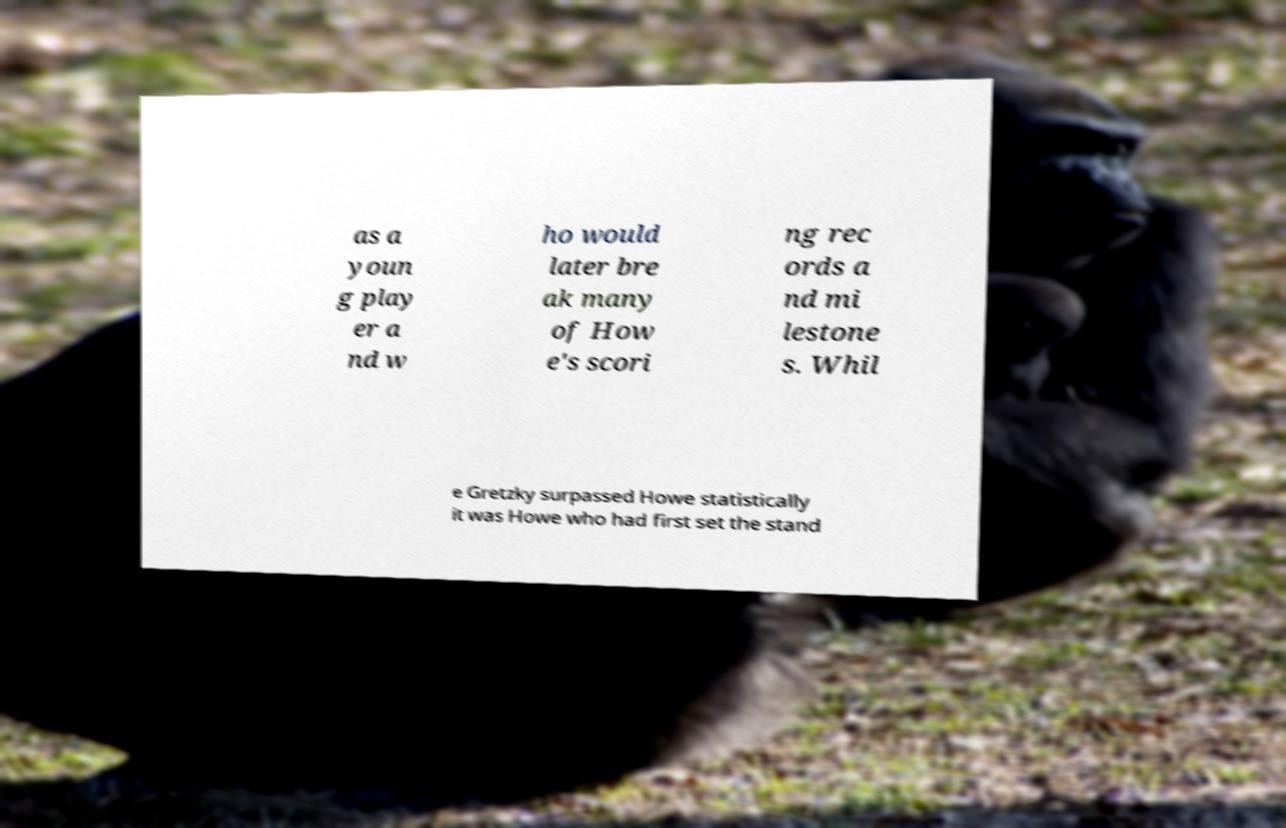Can you accurately transcribe the text from the provided image for me? as a youn g play er a nd w ho would later bre ak many of How e's scori ng rec ords a nd mi lestone s. Whil e Gretzky surpassed Howe statistically it was Howe who had first set the stand 